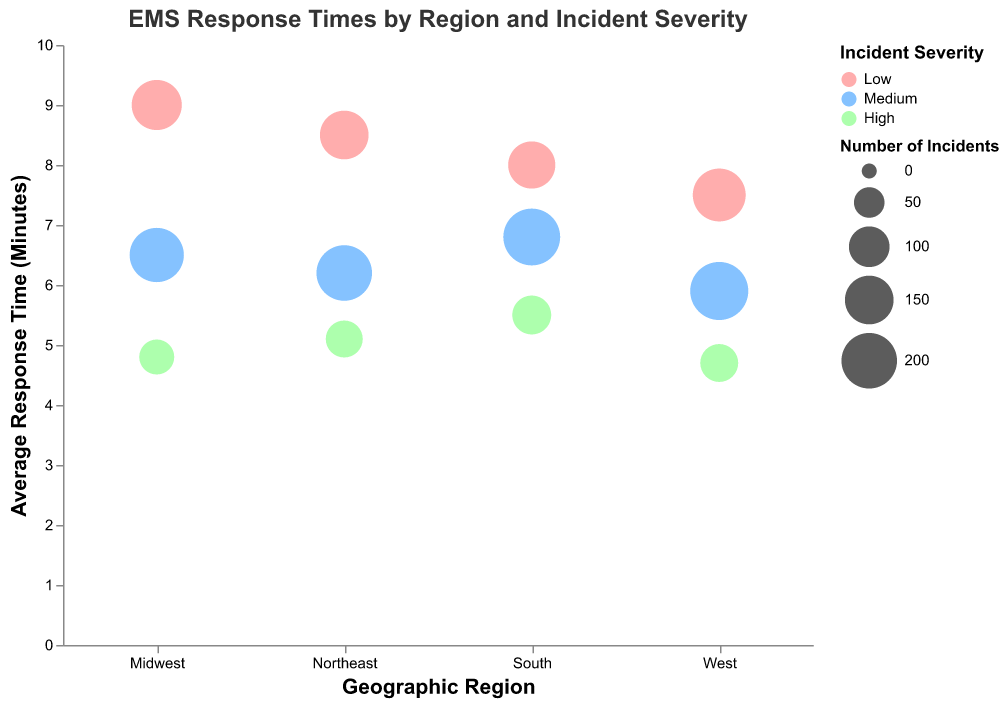What is the title of the figure? The title of the figure is located at the top and it reads "EMS Response Times by Region and Incident Severity."
Answer: "EMS Response Times by Region and Incident Severity" How many data points are there in the figure? Each combination of Geographic Region and Incident Severity forms a unique data point in the figure. There are 4 Geographic Regions (Northeast, Midwest, South, West) and 3 Incident Severities (Low, Medium, High) which make a total of 4 * 3 = 12 data points.
Answer: 12 What color represents "High" Incident Severity? The color representing "High" Incident Severity can be identified by matching it to the legend. The color associated with "High" is green.
Answer: Green Which Geographic Region has the lowest average response time for "High" Incident Severity? Looking at the colors in the figure (green for high severity), the lowest position on the y-axis represents the lowest response time. The West region has the lowest average response time for high severity incidents at 4.7 minutes.
Answer: West What is the average response time for "Medium" Incident Severity in the South region? By looking at the medium severity incidents in the South region, the position on the y-axis will give us the response time. The average response time for Medium Incident Severity in the South is 6.8 minutes.
Answer: 6.8 minutes Which region has the highest number of incidents for "Medium" incident severity? The size of the bubbles represents the number of incidents. By comparing the sizes of the bubbles related to "Medium" Incident Severity across all geographic regions, the largest bubble is for the West region with 220 incidents.
Answer: West What is the difference in average response times between "Low" and "High" Incident Severity in the Midwest region? Find the average response times for both low and high severities in the Midwest. For Low, it is 9.0 minutes and for High, it is 4.8 minutes. The difference is 9.0 - 4.8 = 4.2 minutes.
Answer: 4.2 minutes Which Geographic Region has the largest discrepancy in average response times between Low and High incident severities? To find the largest discrepancy, the absolute differences between Low and High average response times for each region are calculated. Northeast: 8.5 - 5.1 = 3.4 minutes, Midwest: 9.0 - 4.8 = 4.2 minutes, South: 8.0 - 5.5 = 2.5 minutes, West: 7.5 - 4.7 = 2.8 minutes. The Midwest has the largest discrepancy of 4.2 minutes.
Answer: Midwest Which incident severity generally has the quickest response times across all regions? By comparing the positions of the bubbles for Low, Medium, and High incident severities on the y-axis, High severity incidents are generally positioned lower on the y-axis, indicating quicker response times.
Answer: High Compare the number of incidents in the South region for Low and High severity. Which one is higher and by how much? The size of the circles represents the number of incidents. In the South region, the Low severity has 140 incidents and the High severity has 90 incidents. The difference is 140 - 90 = 50 incidents. So, Low severity has 50 more incidents than High severity.
Answer: Low, 50 